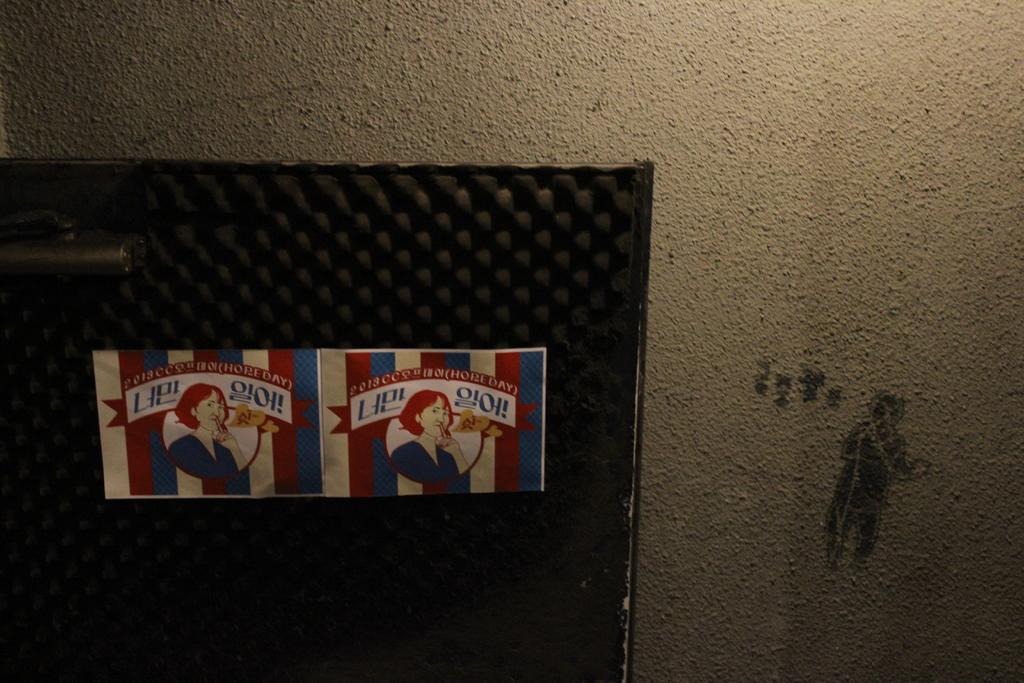Could you give a brief overview of what you see in this image? This is the picture of two posters which are on the black color thing. 